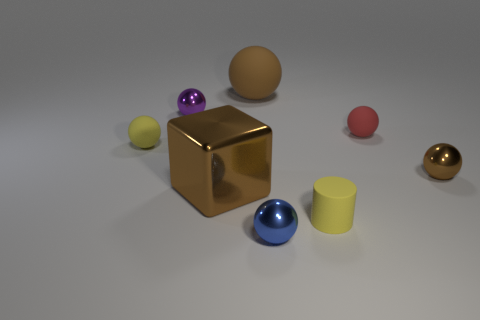How many rubber things are big red objects or spheres?
Make the answer very short. 3. Is the color of the large metallic cube the same as the large rubber object?
Make the answer very short. Yes. Is there any other thing of the same color as the cylinder?
Keep it short and to the point. Yes. Does the shiny thing right of the red matte thing have the same shape as the tiny metal object that is left of the small blue shiny thing?
Give a very brief answer. Yes. How many objects are cylinders or yellow objects that are in front of the brown metal sphere?
Provide a succinct answer. 1. How many other things are there of the same size as the cylinder?
Offer a very short reply. 5. Is the brown ball right of the small blue metallic ball made of the same material as the small yellow thing that is right of the blue shiny ball?
Offer a terse response. No. There is a tiny red matte thing; how many tiny blue balls are on the right side of it?
Provide a succinct answer. 0. What number of brown objects are small metallic spheres or big rubber balls?
Your answer should be very brief. 2. There is a brown thing that is the same size as the red rubber thing; what is its material?
Offer a terse response. Metal. 